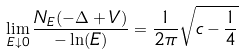<formula> <loc_0><loc_0><loc_500><loc_500>\lim _ { E \downarrow 0 } \frac { N _ { E } ( - \Delta + V ) } { - \ln ( E ) } = \frac { 1 } { 2 \pi } \sqrt { c - \frac { 1 } { 4 } }</formula> 